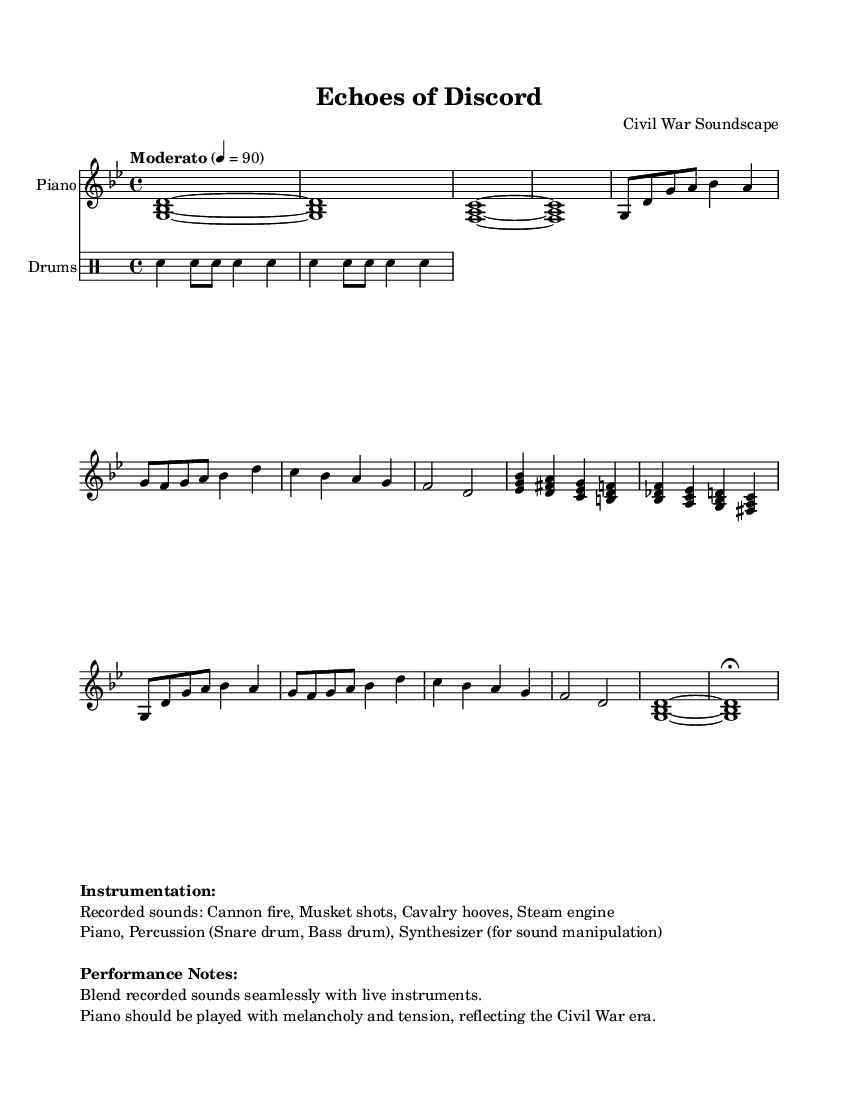What is the key signature of this music? The key signature is indicated in the global variable section of the code. It states `\key g \minor`, which means the piece is in G minor.
Answer: G minor What is the time signature of this music? The time signature is found in the global variable section of the code as `\time 4/4`, specifying that the music is written in common time, which consists of four beats per measure.
Answer: 4/4 What is the tempo marking for this piece? The tempo is given in the global variable section of the code, where it states `\tempo "Moderato" 4 = 90`, indicating a moderate speed of 90 beats per minute.
Answer: Moderato How many different sections are present in the composition? The code outlines multiple sections, including the introduction, Section A, Section B, Section A', and the coda. By counting these distinct parts, we identify five sections total in the composition.
Answer: 5 Which recorded sounds are incorporated into the composition? The sound information is provided in the markup section, indicating the recorded sounds include `Cannon fire, Musket shots, Cavalry hooves, Steam engine`. These sounds are specified for use with the instruments in the piece.
Answer: Cannon fire, Musket shots, Cavalry hooves, Steam engine What instruments are explicitly mentioned in the score? The instrumentation is listed in the markup section of the code, stating `Piano, Percussion (Snare drum, Bass drum), Synthesizer (for sound manipulation)`, which identifies the instruments used in the composition.
Answer: Piano, Percussion, Synthesizer What style or emotion should the piano convey according to the performance notes? The performance notes specify that the `Piano should be played with melancholy and tension, reflecting the Civil War era`, indicating the intended emotional quality and historical context for the performance.
Answer: Melancholy and tension 